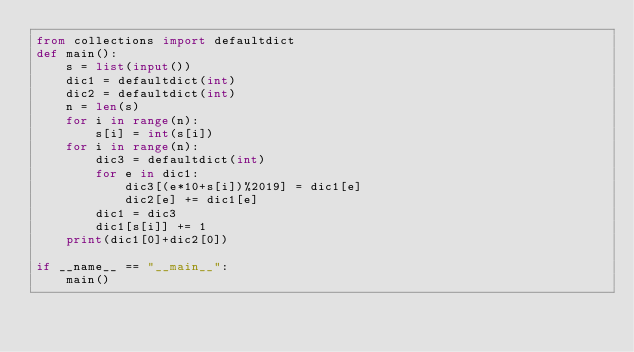<code> <loc_0><loc_0><loc_500><loc_500><_Python_>from collections import defaultdict
def main():
    s = list(input())
    dic1 = defaultdict(int)
    dic2 = defaultdict(int)
    n = len(s)
    for i in range(n):
        s[i] = int(s[i])
    for i in range(n):
        dic3 = defaultdict(int)
        for e in dic1:
            dic3[(e*10+s[i])%2019] = dic1[e]
            dic2[e] += dic1[e]
        dic1 = dic3
        dic1[s[i]] += 1 
    print(dic1[0]+dic2[0])
    
if __name__ == "__main__":
    main()</code> 